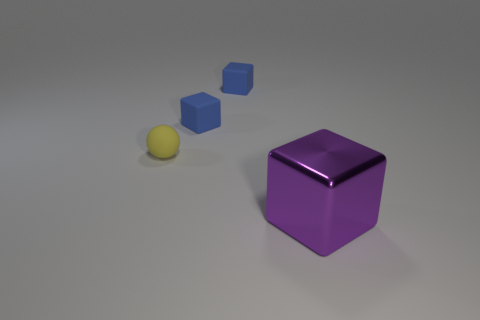There is a object in front of the tiny rubber ball; what is its shape?
Your answer should be compact. Cube. There is a cube in front of the small yellow matte object; is it the same color as the tiny matte sphere?
Your response must be concise. No. Does the cube that is in front of the yellow matte sphere have the same size as the tiny ball?
Give a very brief answer. No. Are there any rubber cubes of the same color as the rubber ball?
Make the answer very short. No. There is a thing that is in front of the small yellow rubber sphere; are there any small rubber balls that are behind it?
Provide a succinct answer. Yes. Are there any large blue spheres made of the same material as the purple thing?
Offer a terse response. No. Are there an equal number of yellow objects in front of the tiny yellow object and big purple shiny cubes?
Your response must be concise. No. What number of small blue matte things have the same shape as the tiny yellow object?
Provide a succinct answer. 0. Is the thing that is in front of the yellow ball made of the same material as the yellow sphere?
Make the answer very short. No. Are there an equal number of blocks in front of the large purple metallic cube and tiny rubber blocks right of the tiny yellow ball?
Provide a succinct answer. No. 